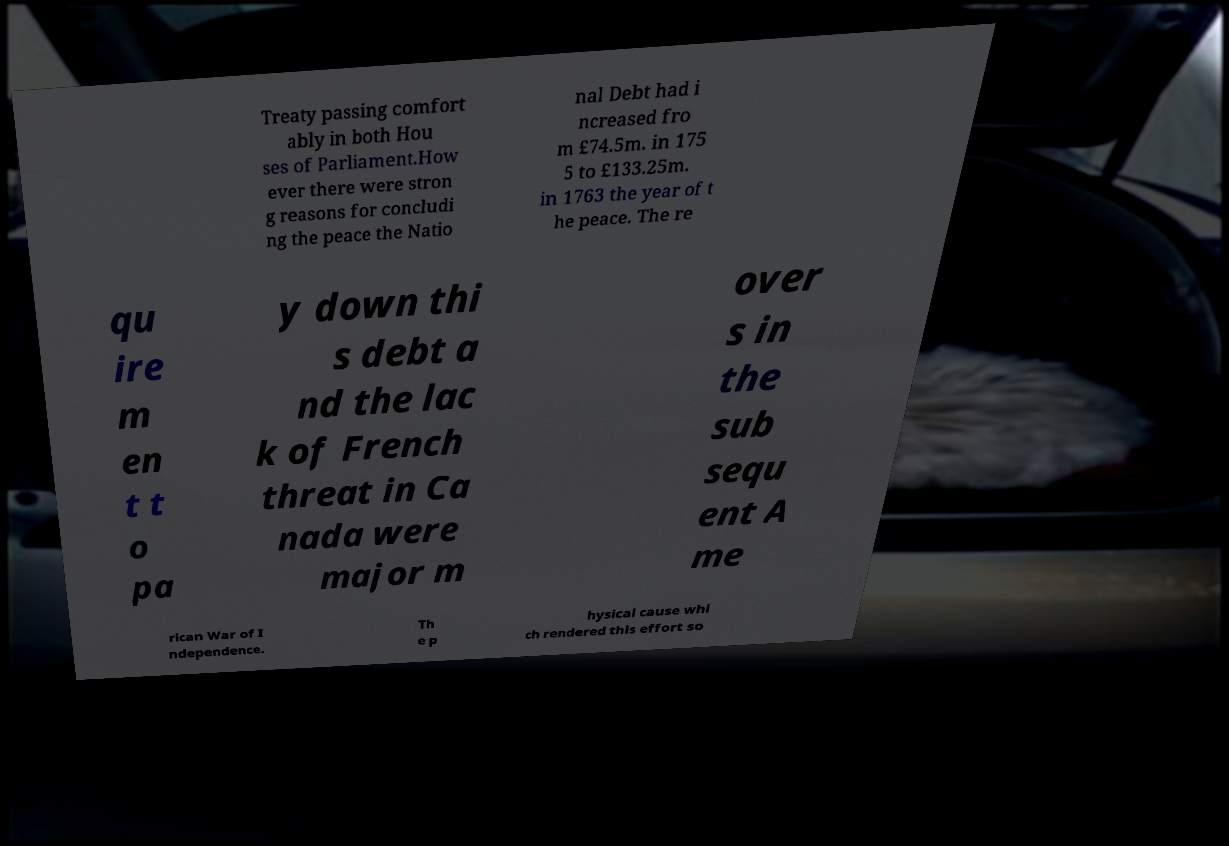For documentation purposes, I need the text within this image transcribed. Could you provide that? Treaty passing comfort ably in both Hou ses of Parliament.How ever there were stron g reasons for concludi ng the peace the Natio nal Debt had i ncreased fro m £74.5m. in 175 5 to £133.25m. in 1763 the year of t he peace. The re qu ire m en t t o pa y down thi s debt a nd the lac k of French threat in Ca nada were major m over s in the sub sequ ent A me rican War of I ndependence. Th e p hysical cause whi ch rendered this effort so 